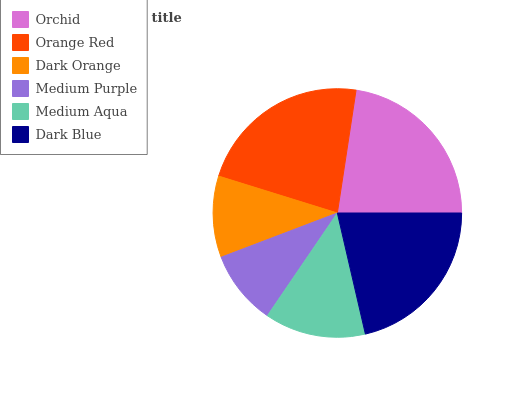Is Medium Purple the minimum?
Answer yes or no. Yes. Is Orange Red the maximum?
Answer yes or no. Yes. Is Dark Orange the minimum?
Answer yes or no. No. Is Dark Orange the maximum?
Answer yes or no. No. Is Orange Red greater than Dark Orange?
Answer yes or no. Yes. Is Dark Orange less than Orange Red?
Answer yes or no. Yes. Is Dark Orange greater than Orange Red?
Answer yes or no. No. Is Orange Red less than Dark Orange?
Answer yes or no. No. Is Dark Blue the high median?
Answer yes or no. Yes. Is Medium Aqua the low median?
Answer yes or no. Yes. Is Dark Orange the high median?
Answer yes or no. No. Is Dark Orange the low median?
Answer yes or no. No. 